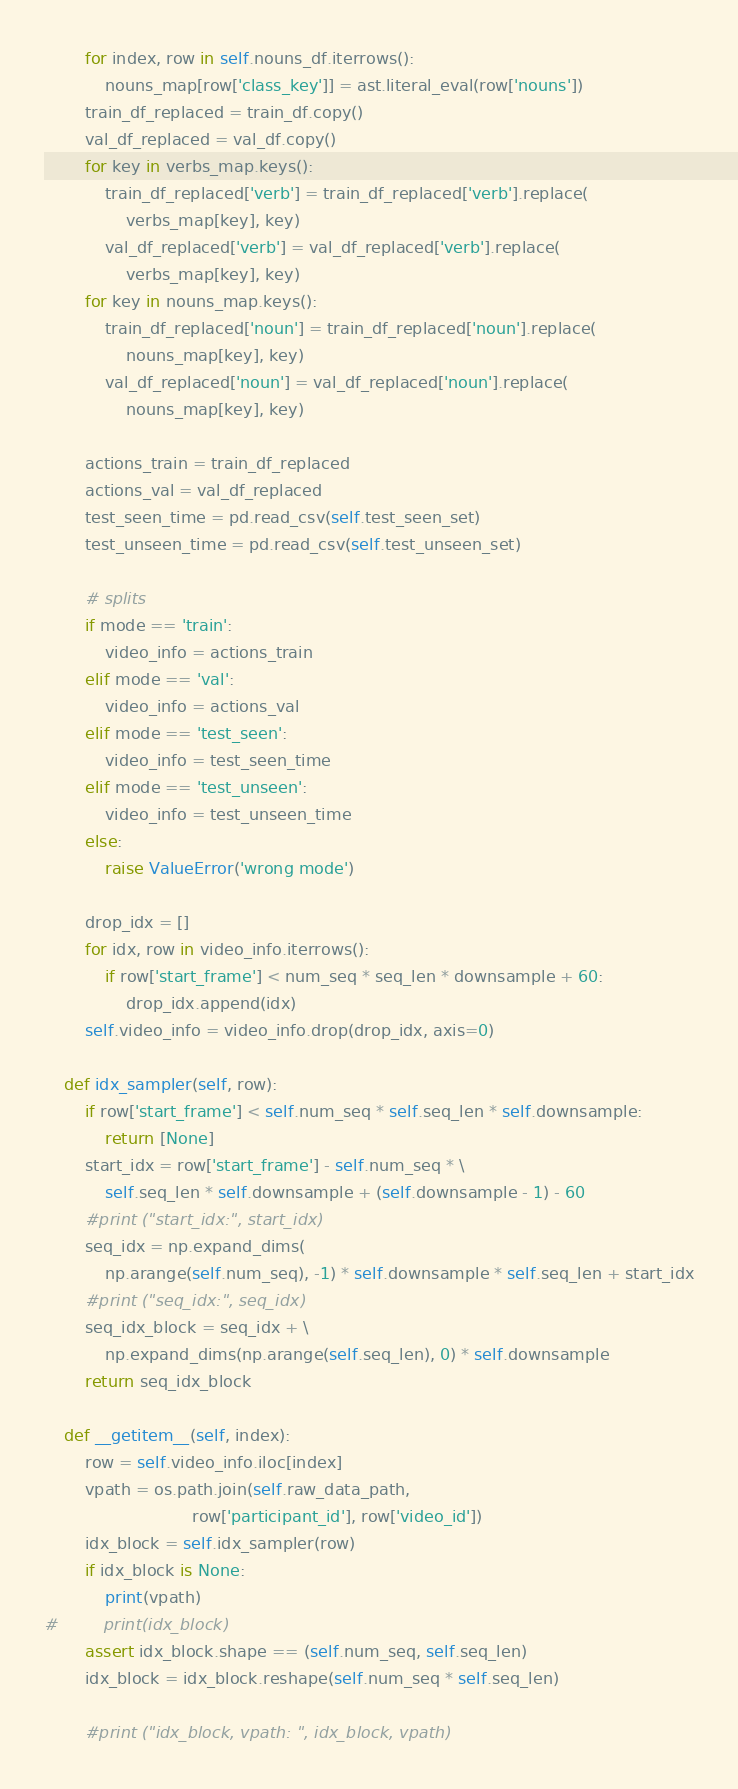<code> <loc_0><loc_0><loc_500><loc_500><_Python_>        for index, row in self.nouns_df.iterrows():
            nouns_map[row['class_key']] = ast.literal_eval(row['nouns'])
        train_df_replaced = train_df.copy()
        val_df_replaced = val_df.copy()
        for key in verbs_map.keys():
            train_df_replaced['verb'] = train_df_replaced['verb'].replace(
                verbs_map[key], key)
            val_df_replaced['verb'] = val_df_replaced['verb'].replace(
                verbs_map[key], key)
        for key in nouns_map.keys():
            train_df_replaced['noun'] = train_df_replaced['noun'].replace(
                nouns_map[key], key)
            val_df_replaced['noun'] = val_df_replaced['noun'].replace(
                nouns_map[key], key)

        actions_train = train_df_replaced
        actions_val = val_df_replaced
        test_seen_time = pd.read_csv(self.test_seen_set)
        test_unseen_time = pd.read_csv(self.test_unseen_set)

        # splits
        if mode == 'train':
            video_info = actions_train
        elif mode == 'val':
            video_info = actions_val
        elif mode == 'test_seen':
            video_info = test_seen_time
        elif mode == 'test_unseen':
            video_info = test_unseen_time
        else:
            raise ValueError('wrong mode')

        drop_idx = []
        for idx, row in video_info.iterrows():
            if row['start_frame'] < num_seq * seq_len * downsample + 60:
                drop_idx.append(idx)
        self.video_info = video_info.drop(drop_idx, axis=0)

    def idx_sampler(self, row):
        if row['start_frame'] < self.num_seq * self.seq_len * self.downsample:
            return [None]
        start_idx = row['start_frame'] - self.num_seq * \
            self.seq_len * self.downsample + (self.downsample - 1) - 60
        #print ("start_idx:", start_idx)
        seq_idx = np.expand_dims(
            np.arange(self.num_seq), -1) * self.downsample * self.seq_len + start_idx
        #print ("seq_idx:", seq_idx)
        seq_idx_block = seq_idx + \
            np.expand_dims(np.arange(self.seq_len), 0) * self.downsample
        return seq_idx_block

    def __getitem__(self, index):
        row = self.video_info.iloc[index]
        vpath = os.path.join(self.raw_data_path,
                             row['participant_id'], row['video_id'])
        idx_block = self.idx_sampler(row)
        if idx_block is None:
            print(vpath)
#         print(idx_block)
        assert idx_block.shape == (self.num_seq, self.seq_len)
        idx_block = idx_block.reshape(self.num_seq * self.seq_len)

        #print ("idx_block, vpath: ", idx_block, vpath)</code> 